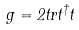<formula> <loc_0><loc_0><loc_500><loc_500>g = 2 t r t ^ { \dag } t</formula> 